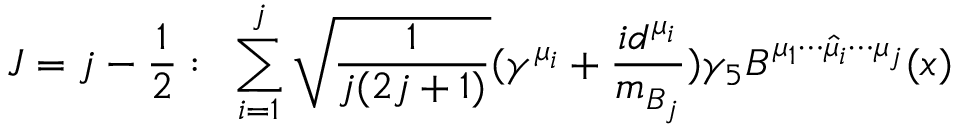Convert formula to latex. <formula><loc_0><loc_0><loc_500><loc_500>J = j - \frac { 1 } { 2 } \colon \, \sum _ { i = 1 } ^ { j } \sqrt { \frac { 1 } { j ( 2 j + 1 ) } } ( \gamma ^ { \mu _ { i } } + \frac { i d ^ { \mu _ { i } } } { m _ { B _ { j } } } ) \gamma _ { 5 } B ^ { \mu _ { 1 } \cdots \widehat { \mu } _ { i } \cdots \mu _ { j } } ( x )</formula> 